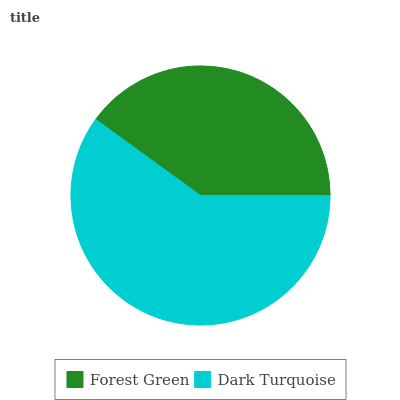Is Forest Green the minimum?
Answer yes or no. Yes. Is Dark Turquoise the maximum?
Answer yes or no. Yes. Is Dark Turquoise the minimum?
Answer yes or no. No. Is Dark Turquoise greater than Forest Green?
Answer yes or no. Yes. Is Forest Green less than Dark Turquoise?
Answer yes or no. Yes. Is Forest Green greater than Dark Turquoise?
Answer yes or no. No. Is Dark Turquoise less than Forest Green?
Answer yes or no. No. Is Dark Turquoise the high median?
Answer yes or no. Yes. Is Forest Green the low median?
Answer yes or no. Yes. Is Forest Green the high median?
Answer yes or no. No. Is Dark Turquoise the low median?
Answer yes or no. No. 